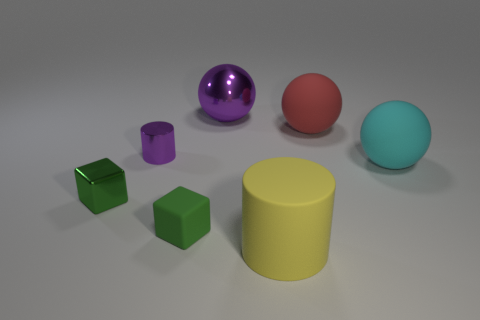What is the shape of the small thing that is the same color as the tiny metal cube?
Offer a very short reply. Cube. There is a purple thing that is the same size as the yellow thing; what shape is it?
Your answer should be compact. Sphere. Is there a big metallic thing that has the same color as the tiny cylinder?
Provide a short and direct response. Yes. Are there an equal number of tiny purple cylinders that are left of the small cylinder and big matte things that are in front of the large purple metallic thing?
Your answer should be compact. No. Is the shape of the tiny green metal thing the same as the purple object that is left of the purple sphere?
Give a very brief answer. No. How many other objects are the same material as the big red thing?
Ensure brevity in your answer.  3. Are there any purple metal cylinders behind the tiny purple metallic thing?
Provide a succinct answer. No. Does the green rubber object have the same size as the cylinder behind the small green rubber thing?
Give a very brief answer. Yes. There is a big matte sphere on the left side of the large cyan thing to the right of the big yellow rubber object; what color is it?
Give a very brief answer. Red. Does the cyan ball have the same size as the green shiny thing?
Provide a succinct answer. No. 